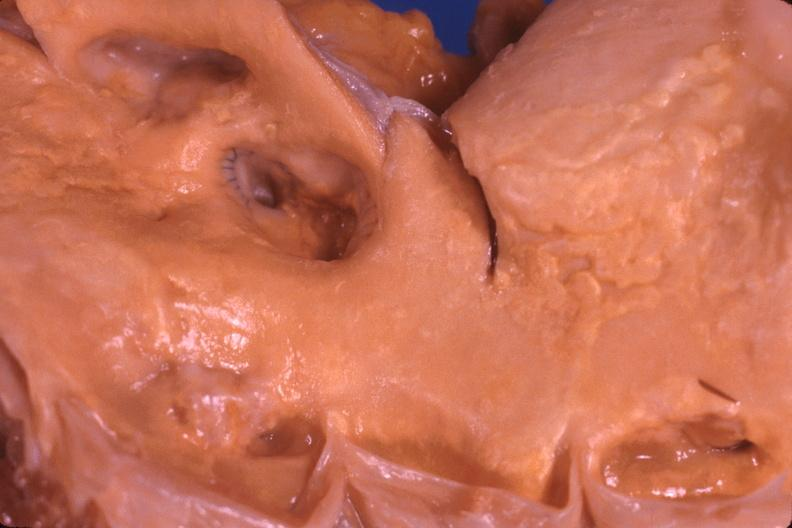what does this image show?
Answer the question using a single word or phrase. Saphenous vein graft anastamosis in aorta 